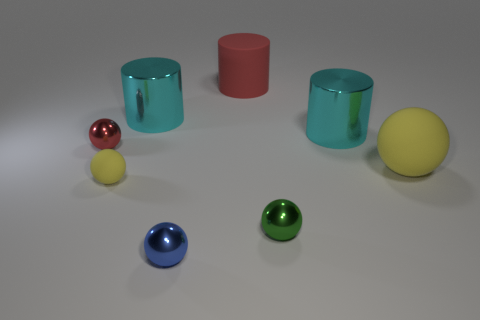What is the material of the large ball that is the same color as the tiny matte thing?
Ensure brevity in your answer.  Rubber. Are there any yellow things behind the large ball?
Ensure brevity in your answer.  No. Are there any green metal objects that have the same shape as the tiny yellow object?
Your response must be concise. Yes. Does the yellow thing right of the tiny yellow object have the same shape as the tiny metal object in front of the green ball?
Provide a short and direct response. Yes. Is there a cyan metal cylinder of the same size as the green object?
Your answer should be compact. No. Are there an equal number of big red matte things to the left of the blue metal sphere and yellow rubber things on the left side of the green object?
Offer a terse response. No. Is the small ball that is behind the large ball made of the same material as the big yellow ball that is in front of the big red object?
Ensure brevity in your answer.  No. What is the material of the big yellow object?
Provide a short and direct response. Rubber. What number of other objects are there of the same color as the tiny rubber sphere?
Ensure brevity in your answer.  1. Is the color of the matte cylinder the same as the small rubber object?
Your response must be concise. No. 